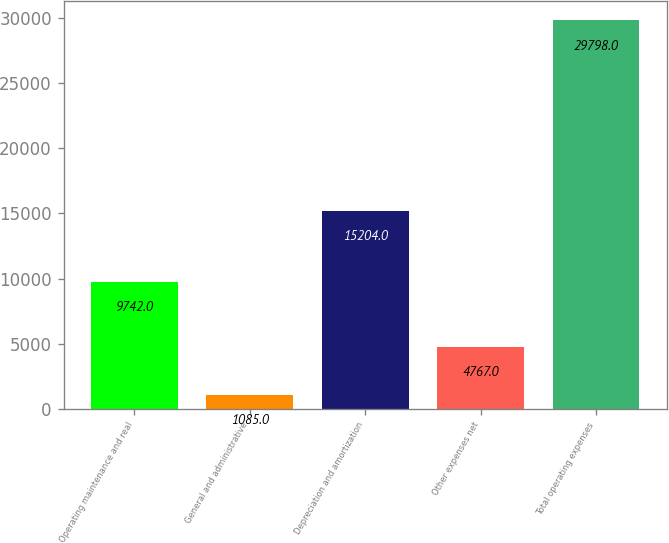<chart> <loc_0><loc_0><loc_500><loc_500><bar_chart><fcel>Operating maintenance and real<fcel>General and administrative<fcel>Depreciation and amortization<fcel>Other expenses net<fcel>Total operating expenses<nl><fcel>9742<fcel>1085<fcel>15204<fcel>4767<fcel>29798<nl></chart> 